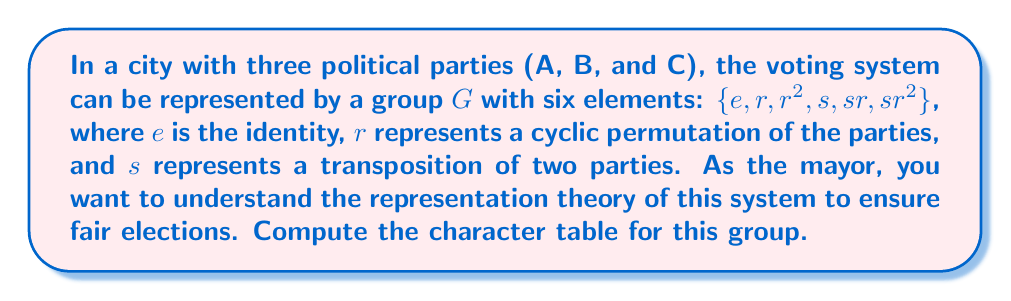Help me with this question. Let's approach this step-by-step:

1) First, identify the conjugacy classes:
   Class 1: $\{e\}$ (identity)
   Class 2: $\{r, r^2\}$ (3-cycles)
   Class 3: $\{s, sr, sr^2\}$ (transpositions)

2) The number of irreducible representations equals the number of conjugacy classes, so we have 3 irreducible representations.

3) The dimensions of these representations must satisfy:
   $1^2 + 1^2 + 2^2 = 6$ (order of the group)
   So, we have two 1-dimensional representations and one 2-dimensional representation.

4) Let's call these representations $\chi_1$ (trivial), $\chi_2$, and $\chi_3$ (2-dimensional).

5) For $\chi_1$, all characters are 1.

6) For $\chi_2$:
   $\chi_2(e) = 1$
   $\chi_2(r) = \chi_2(r^2) = \omega$ (where $\omega$ is a cube root of unity, $\omega^3 = 1$)
   $\chi_2(s) = \chi_2(sr) = \chi_2(sr^2) = 1$

7) For $\chi_3$, we can deduce:
   $\chi_3(e) = 2$
   $\chi_3(r) = \chi_3(r^2) = -1$
   $\chi_3(s) = \chi_3(sr) = \chi_3(sr^2) = 0$

8) The character table is thus:

   $$
   \begin{array}{c|ccc}
     & \{e\} & \{r, r^2\} & \{s, sr, sr^2\} \\
   \hline
   \chi_1 & 1 & 1 & 1 \\
   \chi_2 & 1 & \omega & 1 \\
   \chi_3 & 2 & -1 & 0
   \end{array}
   $$

   where $\omega = e^{2\pi i/3} = -\frac{1}{2} + i\frac{\sqrt{3}}{2}$
Answer: $$
\begin{array}{c|ccc}
  & \{e\} & \{r, r^2\} & \{s, sr, sr^2\} \\
\hline
\chi_1 & 1 & 1 & 1 \\
\chi_2 & 1 & \omega & 1 \\
\chi_3 & 2 & -1 & 0
\end{array}
$$
where $\omega = e^{2\pi i/3}$ 